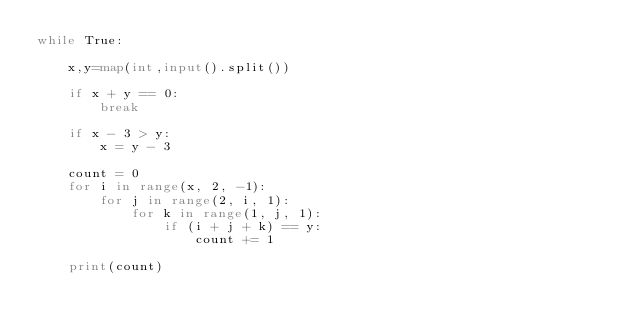Convert code to text. <code><loc_0><loc_0><loc_500><loc_500><_Python_>while True:

    x,y=map(int,input().split())

    if x + y == 0:
        break

    if x - 3 > y:
        x = y - 3

    count = 0
    for i in range(x, 2, -1):
        for j in range(2, i, 1):
            for k in range(1, j, 1):
                if (i + j + k) == y:
                    count += 1

    print(count)


</code> 